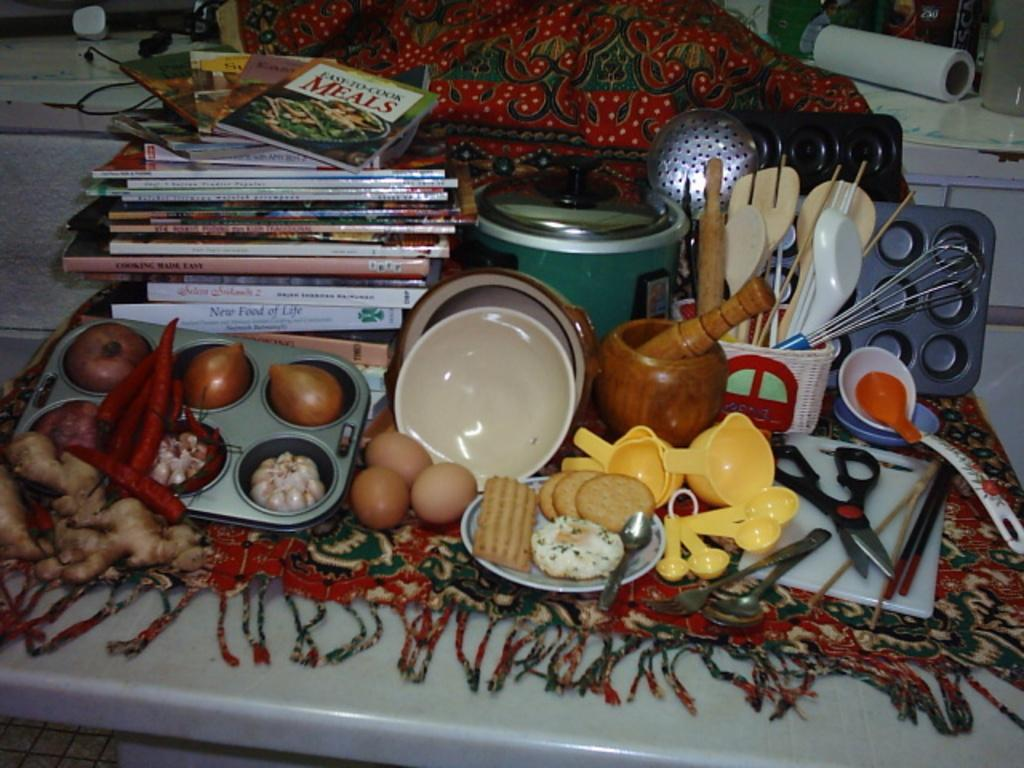<image>
Create a compact narrative representing the image presented. A table full of snacks and a cookbook of Easy to Cook Meals. 